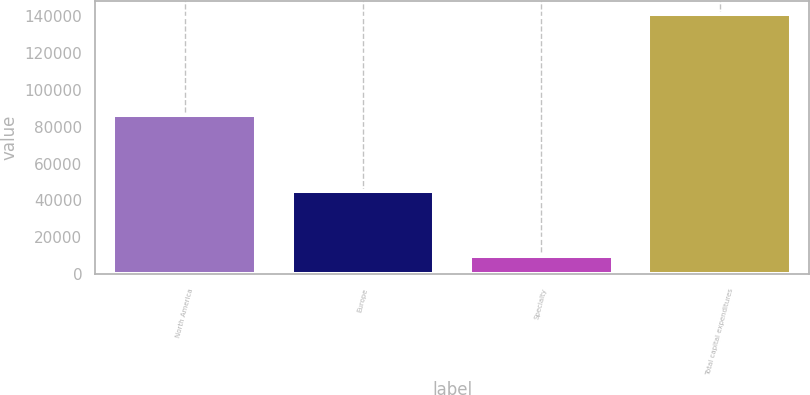Convert chart. <chart><loc_0><loc_0><loc_500><loc_500><bar_chart><fcel>North America<fcel>Europe<fcel>Specialty<fcel>Total capital expenditures<nl><fcel>86172<fcel>44896<fcel>9882<fcel>140950<nl></chart> 